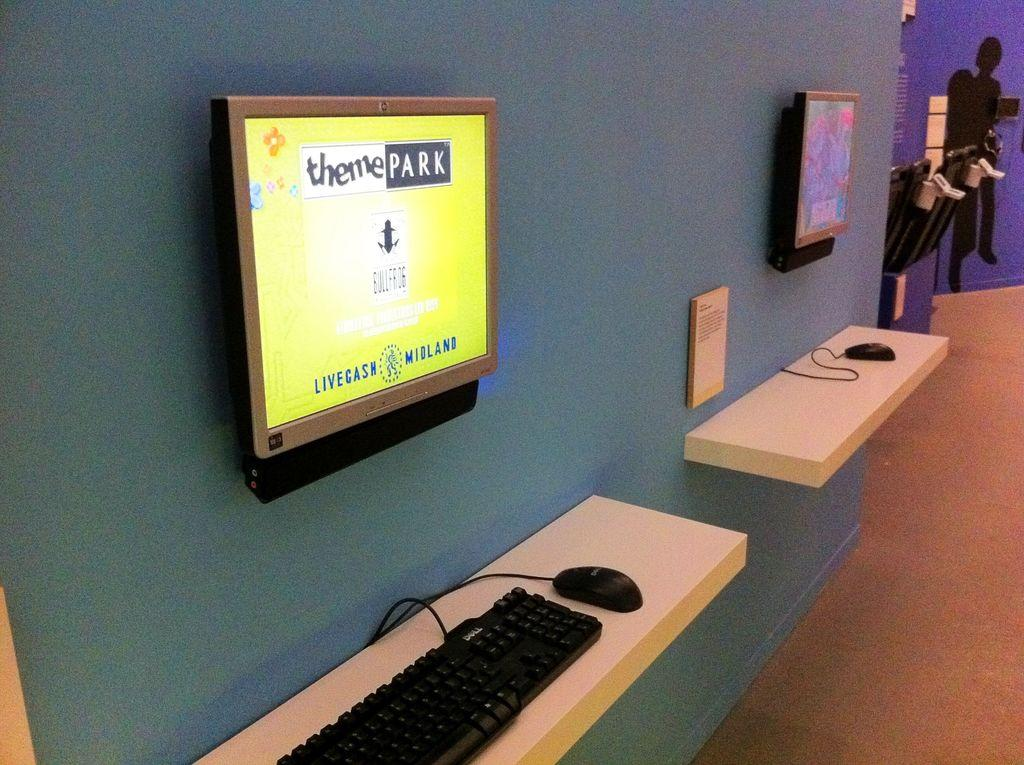<image>
Summarize the visual content of the image. a screen on a wall that says 'theme park' on it 